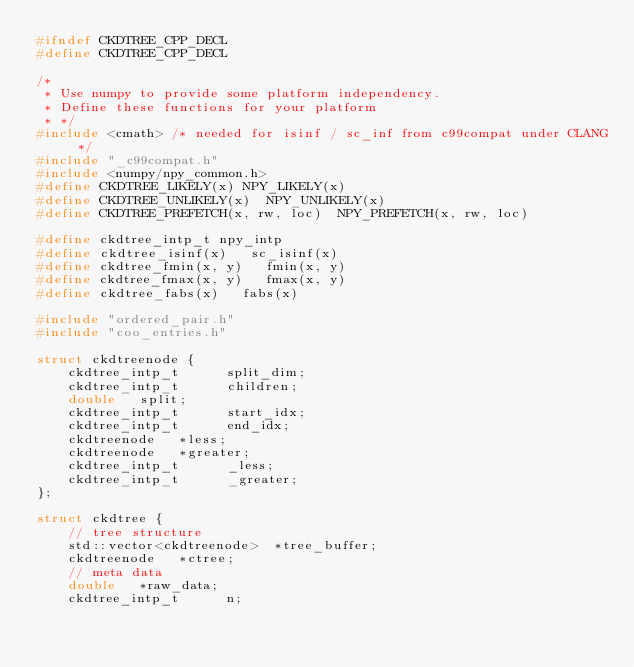Convert code to text. <code><loc_0><loc_0><loc_500><loc_500><_C_>#ifndef CKDTREE_CPP_DECL
#define CKDTREE_CPP_DECL

/*
 * Use numpy to provide some platform independency.
 * Define these functions for your platform
 * */
#include <cmath> /* needed for isinf / sc_inf from c99compat under CLANG */
#include "_c99compat.h"
#include <numpy/npy_common.h>
#define CKDTREE_LIKELY(x) NPY_LIKELY(x)
#define CKDTREE_UNLIKELY(x)  NPY_UNLIKELY(x)
#define CKDTREE_PREFETCH(x, rw, loc)  NPY_PREFETCH(x, rw, loc)

#define ckdtree_intp_t npy_intp
#define ckdtree_isinf(x)   sc_isinf(x)
#define ckdtree_fmin(x, y)   fmin(x, y)
#define ckdtree_fmax(x, y)   fmax(x, y)
#define ckdtree_fabs(x)   fabs(x)

#include "ordered_pair.h"
#include "coo_entries.h"

struct ckdtreenode {
    ckdtree_intp_t      split_dim;
    ckdtree_intp_t      children;
    double   split;
    ckdtree_intp_t      start_idx;
    ckdtree_intp_t      end_idx;
    ckdtreenode   *less;
    ckdtreenode   *greater;
    ckdtree_intp_t      _less;
    ckdtree_intp_t      _greater;
};

struct ckdtree {
    // tree structure
    std::vector<ckdtreenode>  *tree_buffer;
    ckdtreenode   *ctree;
    // meta data
    double   *raw_data;
    ckdtree_intp_t      n;</code> 